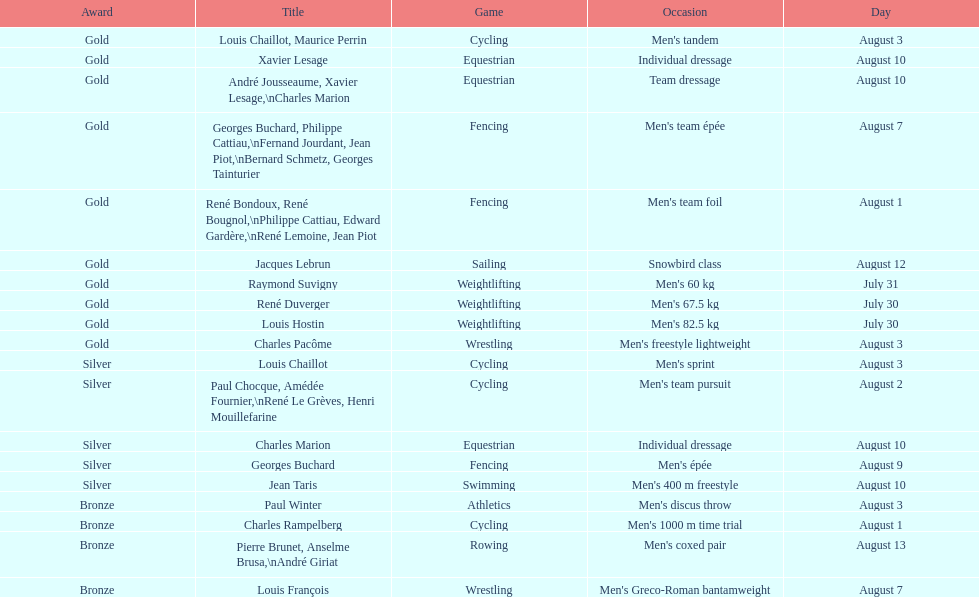Which event won the most medals? Cycling. 